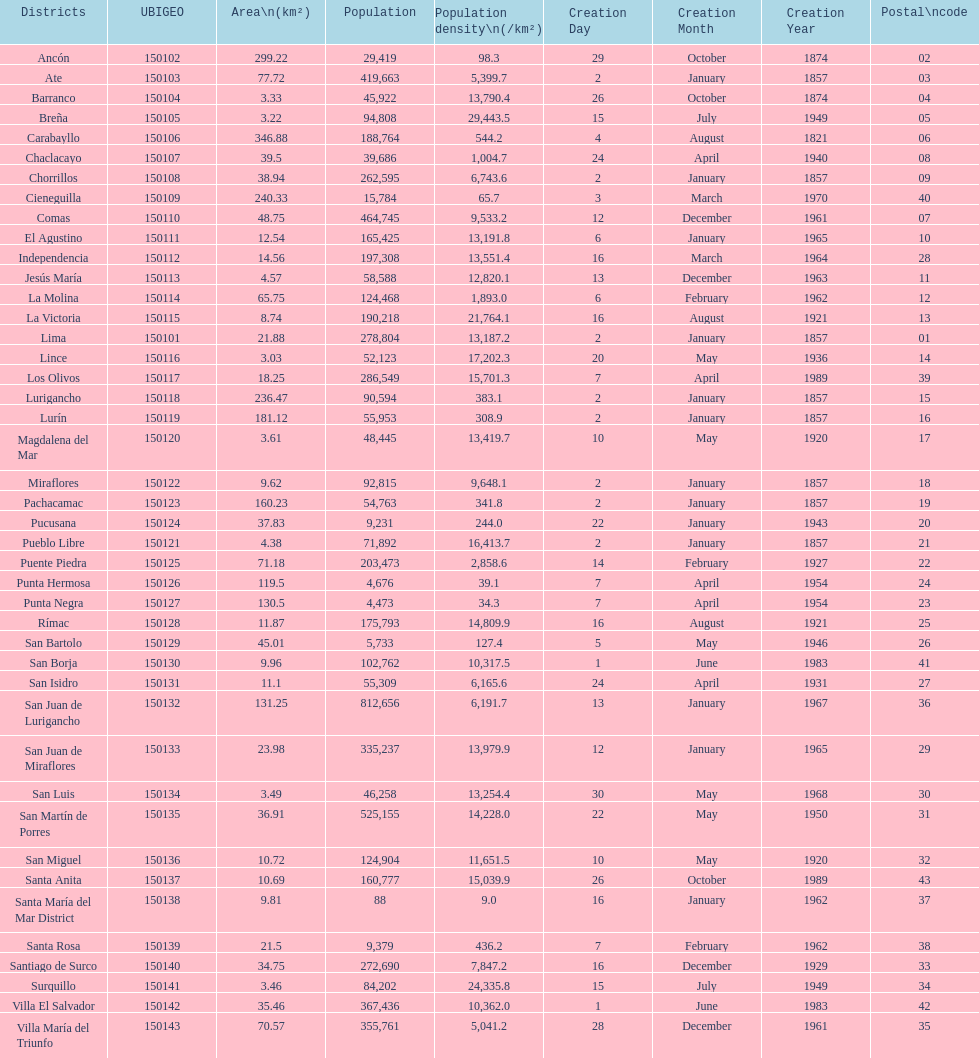What is the total number of districts of lima? 43. 